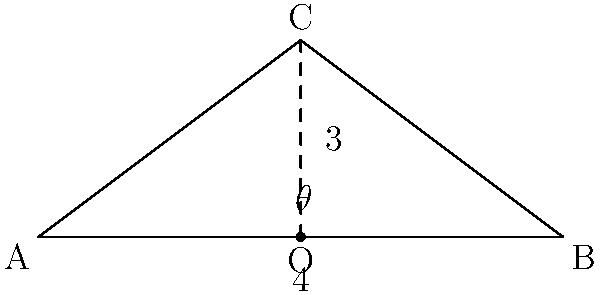In the simple house cross-section shown above, what is the optimal angle $\theta$ for the sloped roof to maximize rainfall runoff? Express your answer in degrees, rounded to the nearest whole number. To determine the optimal angle for maximum rainfall runoff, we need to follow these steps:

1. Recognize that the optimal angle for water runoff is typically around 45°. This angle provides a balance between gravity-driven flow and the roof's ability to shed water quickly.

2. In the given diagram, we have a right triangle. We can use the trigonometric ratio tangent to find the angle.

3. The triangle has a base (half of the house width) of 4 units and a height of 3 units.

4. The tangent of the angle $\theta$ is the ratio of the opposite side to the adjacent side:

   $$\tan(\theta) = \frac{\text{opposite}}{\text{adjacent}} = \frac{3}{4}$$

5. To find $\theta$, we need to use the inverse tangent (arctangent) function:

   $$\theta = \arctan(\frac{3}{4})$$

6. Using a calculator or mathematical tables:

   $$\theta \approx 36.87°$$

7. Rounding to the nearest whole number:

   $$\theta \approx 37°$$

This angle is close to the optimal 45° for rainfall runoff, providing a good balance between water flow and roof stability.
Answer: 37° 